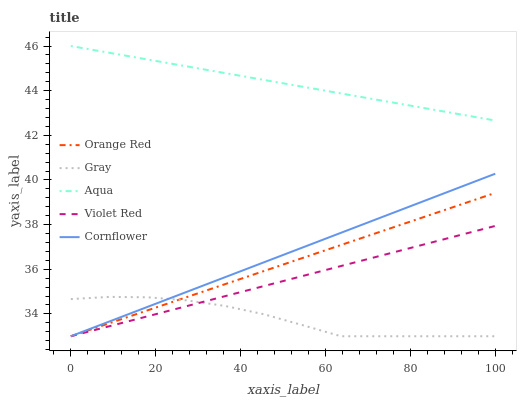Does Gray have the minimum area under the curve?
Answer yes or no. Yes. Does Aqua have the maximum area under the curve?
Answer yes or no. Yes. Does Violet Red have the minimum area under the curve?
Answer yes or no. No. Does Violet Red have the maximum area under the curve?
Answer yes or no. No. Is Orange Red the smoothest?
Answer yes or no. Yes. Is Gray the roughest?
Answer yes or no. Yes. Is Violet Red the smoothest?
Answer yes or no. No. Is Violet Red the roughest?
Answer yes or no. No. Does Gray have the lowest value?
Answer yes or no. Yes. Does Aqua have the lowest value?
Answer yes or no. No. Does Aqua have the highest value?
Answer yes or no. Yes. Does Violet Red have the highest value?
Answer yes or no. No. Is Orange Red less than Aqua?
Answer yes or no. Yes. Is Aqua greater than Violet Red?
Answer yes or no. Yes. Does Cornflower intersect Orange Red?
Answer yes or no. Yes. Is Cornflower less than Orange Red?
Answer yes or no. No. Is Cornflower greater than Orange Red?
Answer yes or no. No. Does Orange Red intersect Aqua?
Answer yes or no. No. 